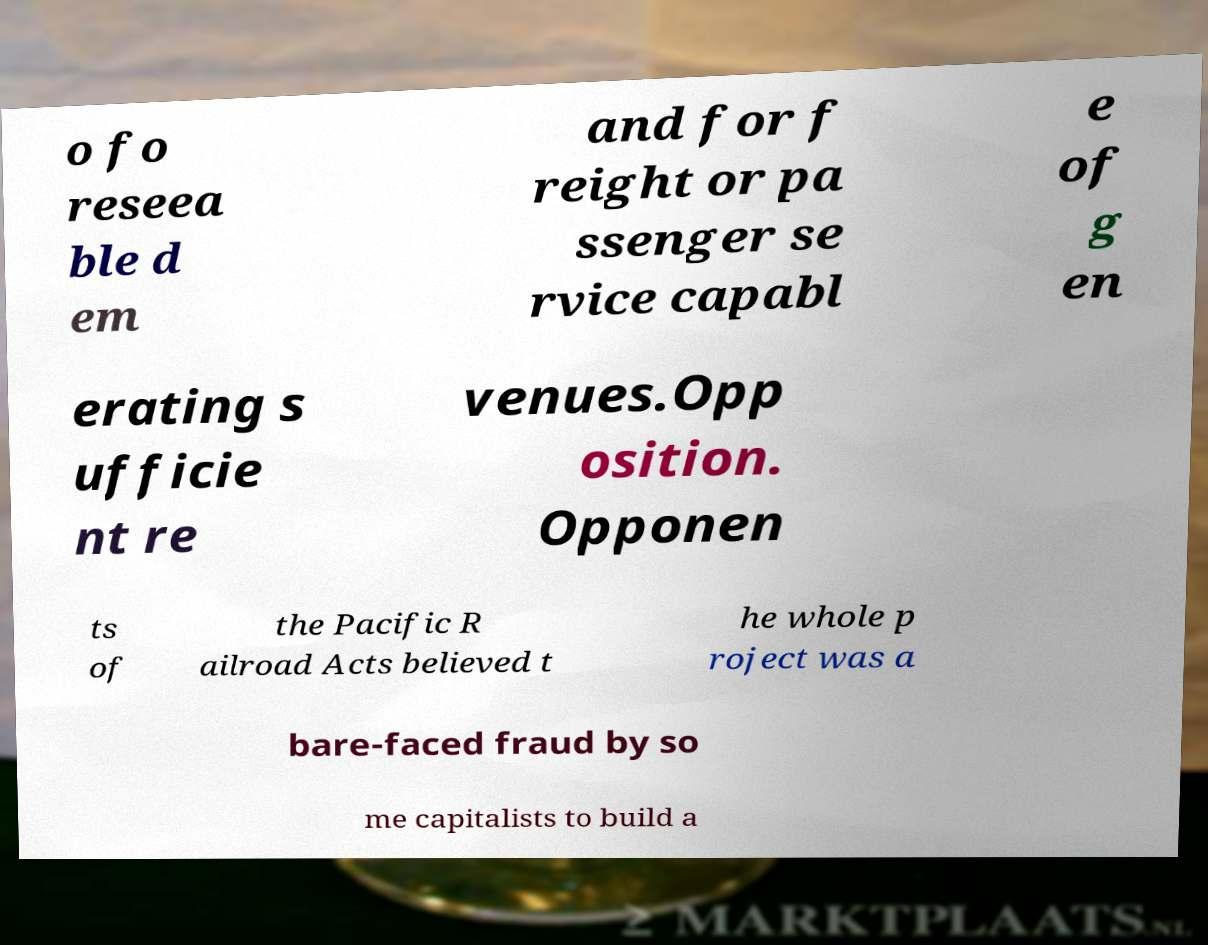Could you extract and type out the text from this image? o fo reseea ble d em and for f reight or pa ssenger se rvice capabl e of g en erating s ufficie nt re venues.Opp osition. Opponen ts of the Pacific R ailroad Acts believed t he whole p roject was a bare-faced fraud by so me capitalists to build a 